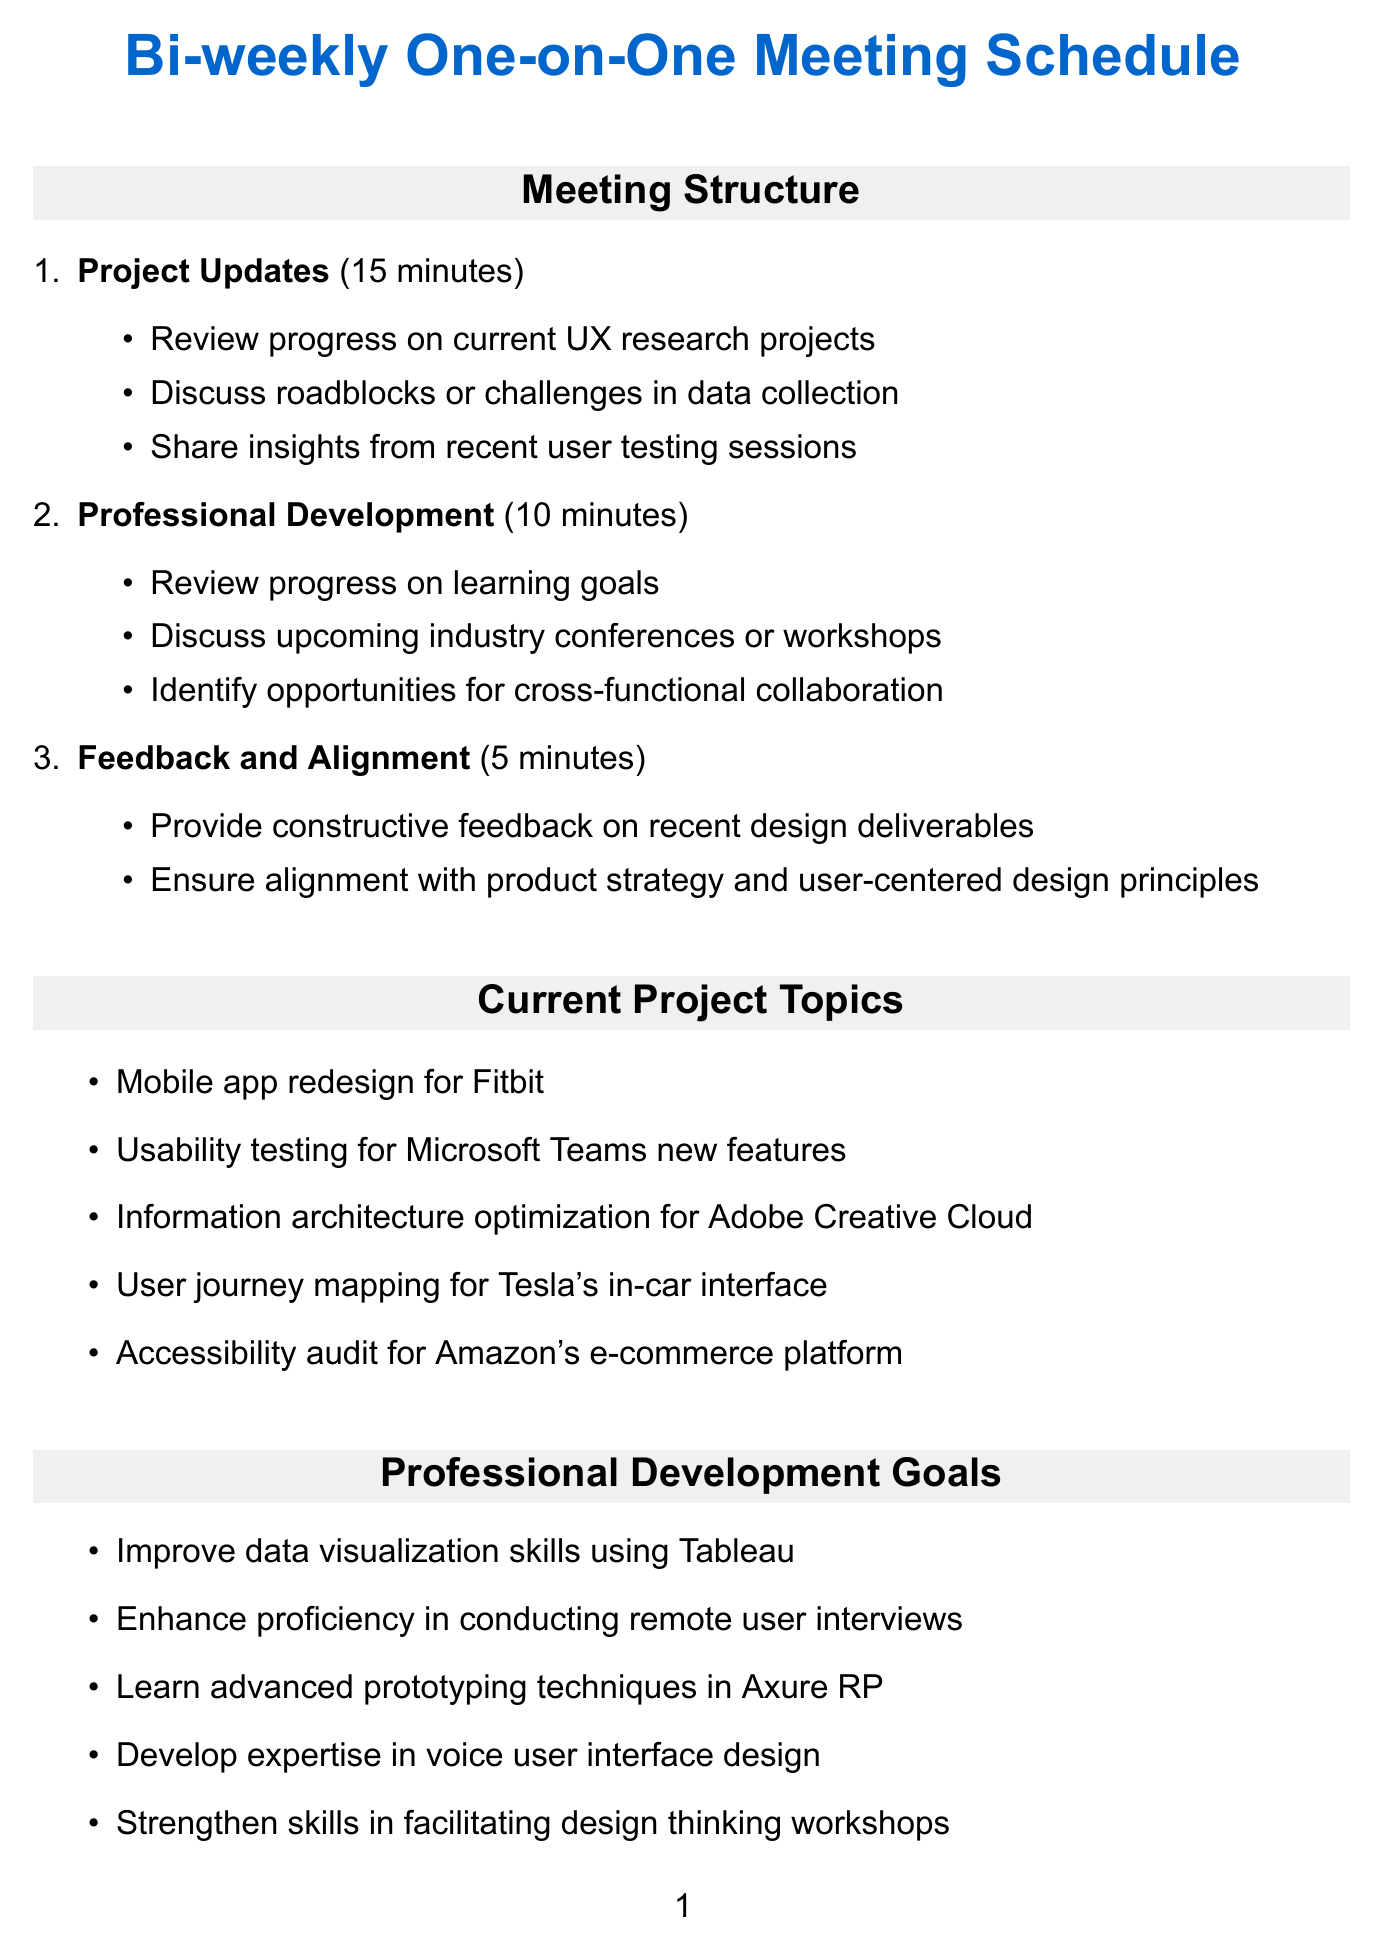What is the duration of the Project Updates section? The duration of the Project Updates section is specified in the meeting structure as 15 minutes.
Answer: 15 minutes How many project topics are listed? The document details five current project topics listed under the current project topics section.
Answer: 5 What is one of the professional development goals? There are several goals provided in the document, including "Improve data visualization skills using Tableau."
Answer: Improve data visualization skills using Tableau What tool is mentioned for collaborative whiteboarding? The document specifies "Miro" as the tool for collaborative whiteboarding in remote design sessions.
Answer: Miro What is the total duration of the meeting structure in minutes? The total duration includes 15 minutes for project updates, 10 minutes for professional development, and 5 minutes for feedback, adding up to 30 minutes total.
Answer: 30 minutes What is one action item listed in the document? "Schedule usability testing sessions for the Fitbit app redesign" is one of the action items mentioned.
Answer: Schedule usability testing sessions for the Fitbit app redesign Which section follows the Professional Development section? The Feedback and Alignment section follows the Professional Development section in the meeting structure.
Answer: Feedback and Alignment What is the purpose of UserTesting.com? The document states that UserTesting.com is intended as a remote user testing platform.
Answer: Remote user testing platform 